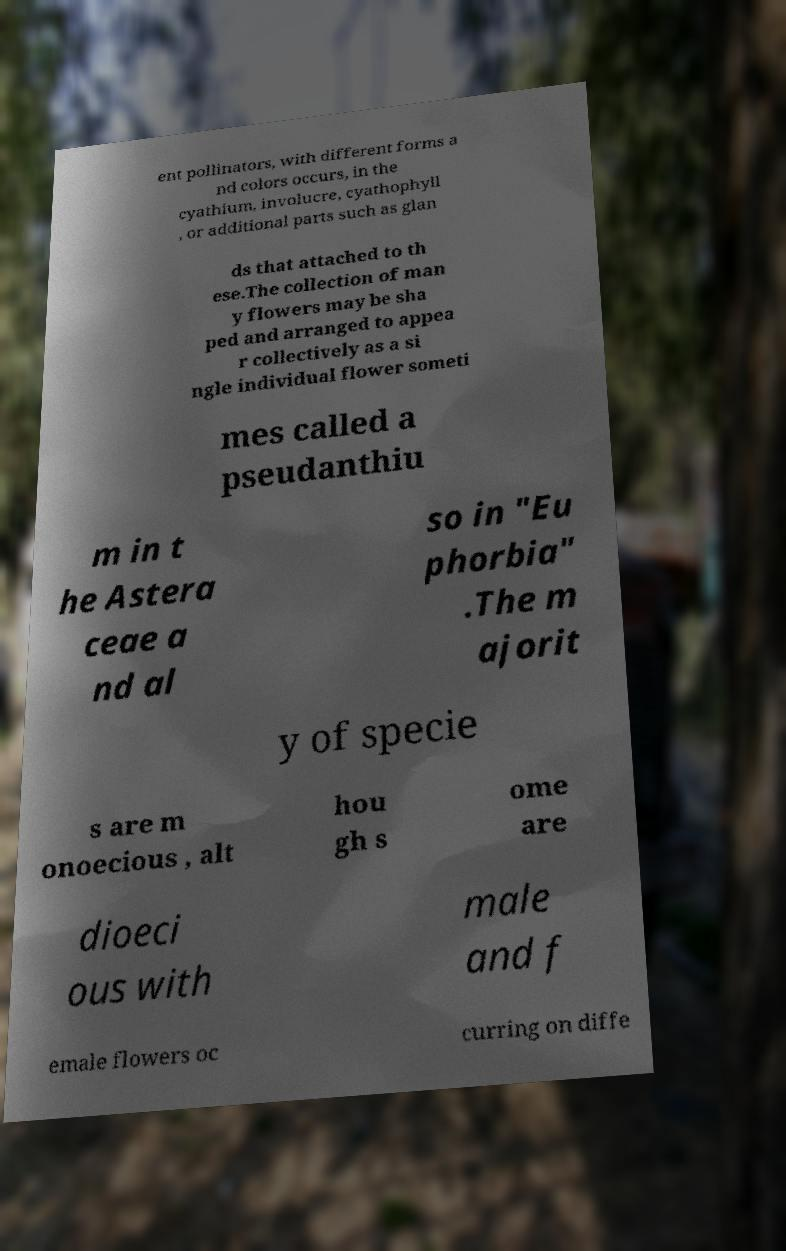There's text embedded in this image that I need extracted. Can you transcribe it verbatim? ent pollinators, with different forms a nd colors occurs, in the cyathium, involucre, cyathophyll , or additional parts such as glan ds that attached to th ese.The collection of man y flowers may be sha ped and arranged to appea r collectively as a si ngle individual flower someti mes called a pseudanthiu m in t he Astera ceae a nd al so in "Eu phorbia" .The m ajorit y of specie s are m onoecious , alt hou gh s ome are dioeci ous with male and f emale flowers oc curring on diffe 